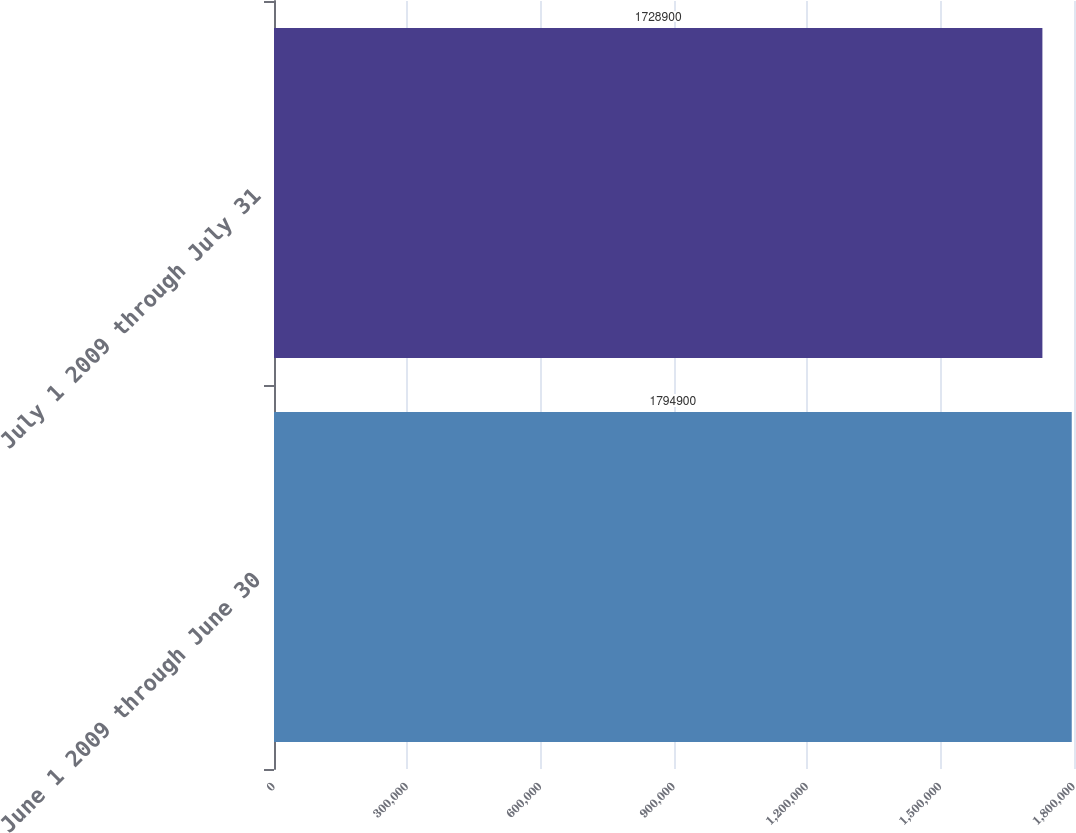Convert chart. <chart><loc_0><loc_0><loc_500><loc_500><bar_chart><fcel>June 1 2009 through June 30<fcel>July 1 2009 through July 31<nl><fcel>1.7949e+06<fcel>1.7289e+06<nl></chart> 